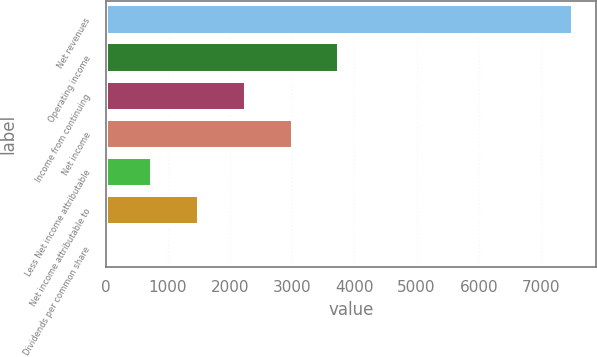<chart> <loc_0><loc_0><loc_500><loc_500><bar_chart><fcel>Net revenues<fcel>Operating income<fcel>Income from continuing<fcel>Net income<fcel>Less Net income attributable<fcel>Net income attributable to<fcel>Dividends per common share<nl><fcel>7515<fcel>3758.32<fcel>2255.66<fcel>3006.99<fcel>752.99<fcel>1504.33<fcel>1.65<nl></chart> 